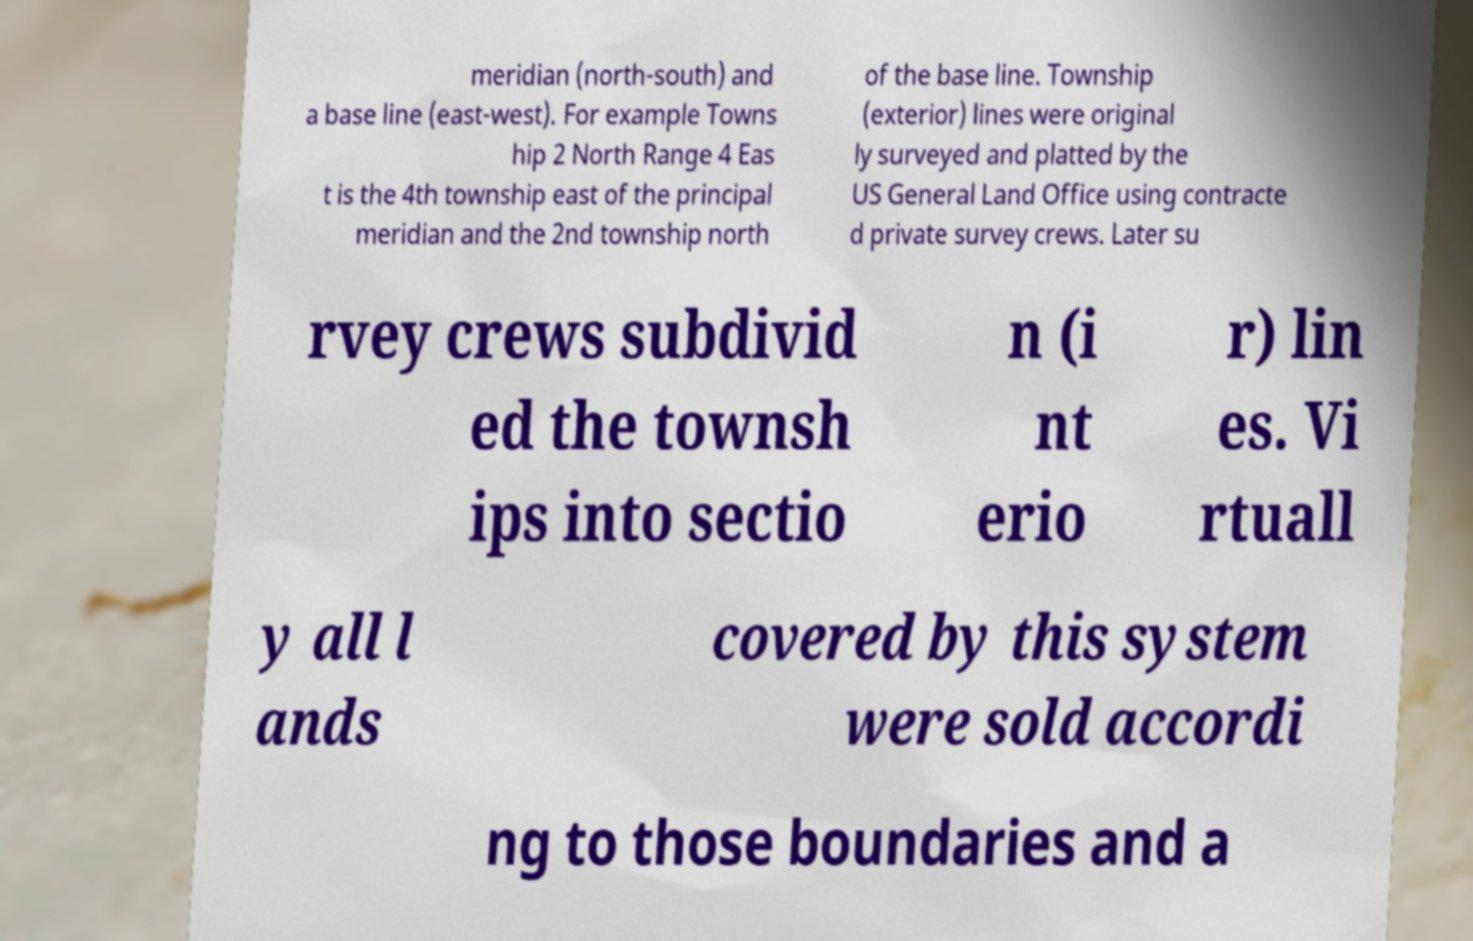Can you read and provide the text displayed in the image?This photo seems to have some interesting text. Can you extract and type it out for me? meridian (north-south) and a base line (east-west). For example Towns hip 2 North Range 4 Eas t is the 4th township east of the principal meridian and the 2nd township north of the base line. Township (exterior) lines were original ly surveyed and platted by the US General Land Office using contracte d private survey crews. Later su rvey crews subdivid ed the townsh ips into sectio n (i nt erio r) lin es. Vi rtuall y all l ands covered by this system were sold accordi ng to those boundaries and a 